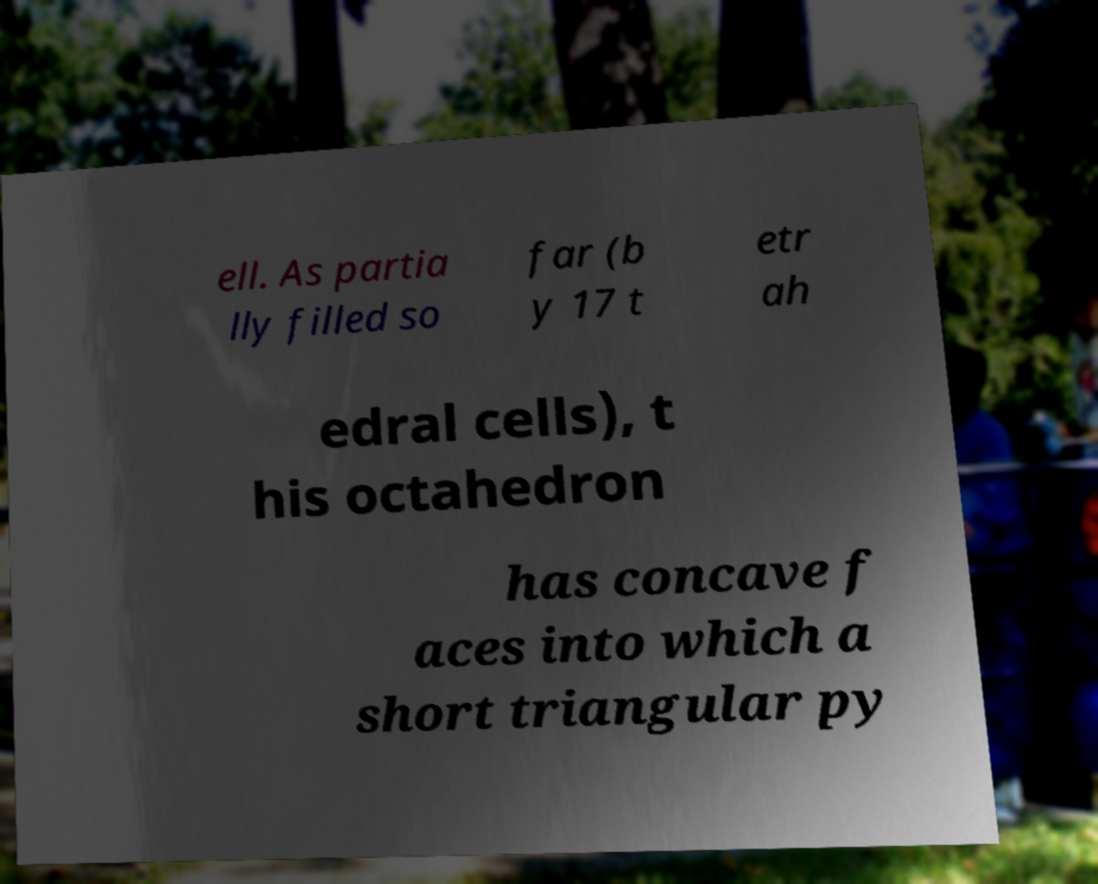Could you assist in decoding the text presented in this image and type it out clearly? ell. As partia lly filled so far (b y 17 t etr ah edral cells), t his octahedron has concave f aces into which a short triangular py 